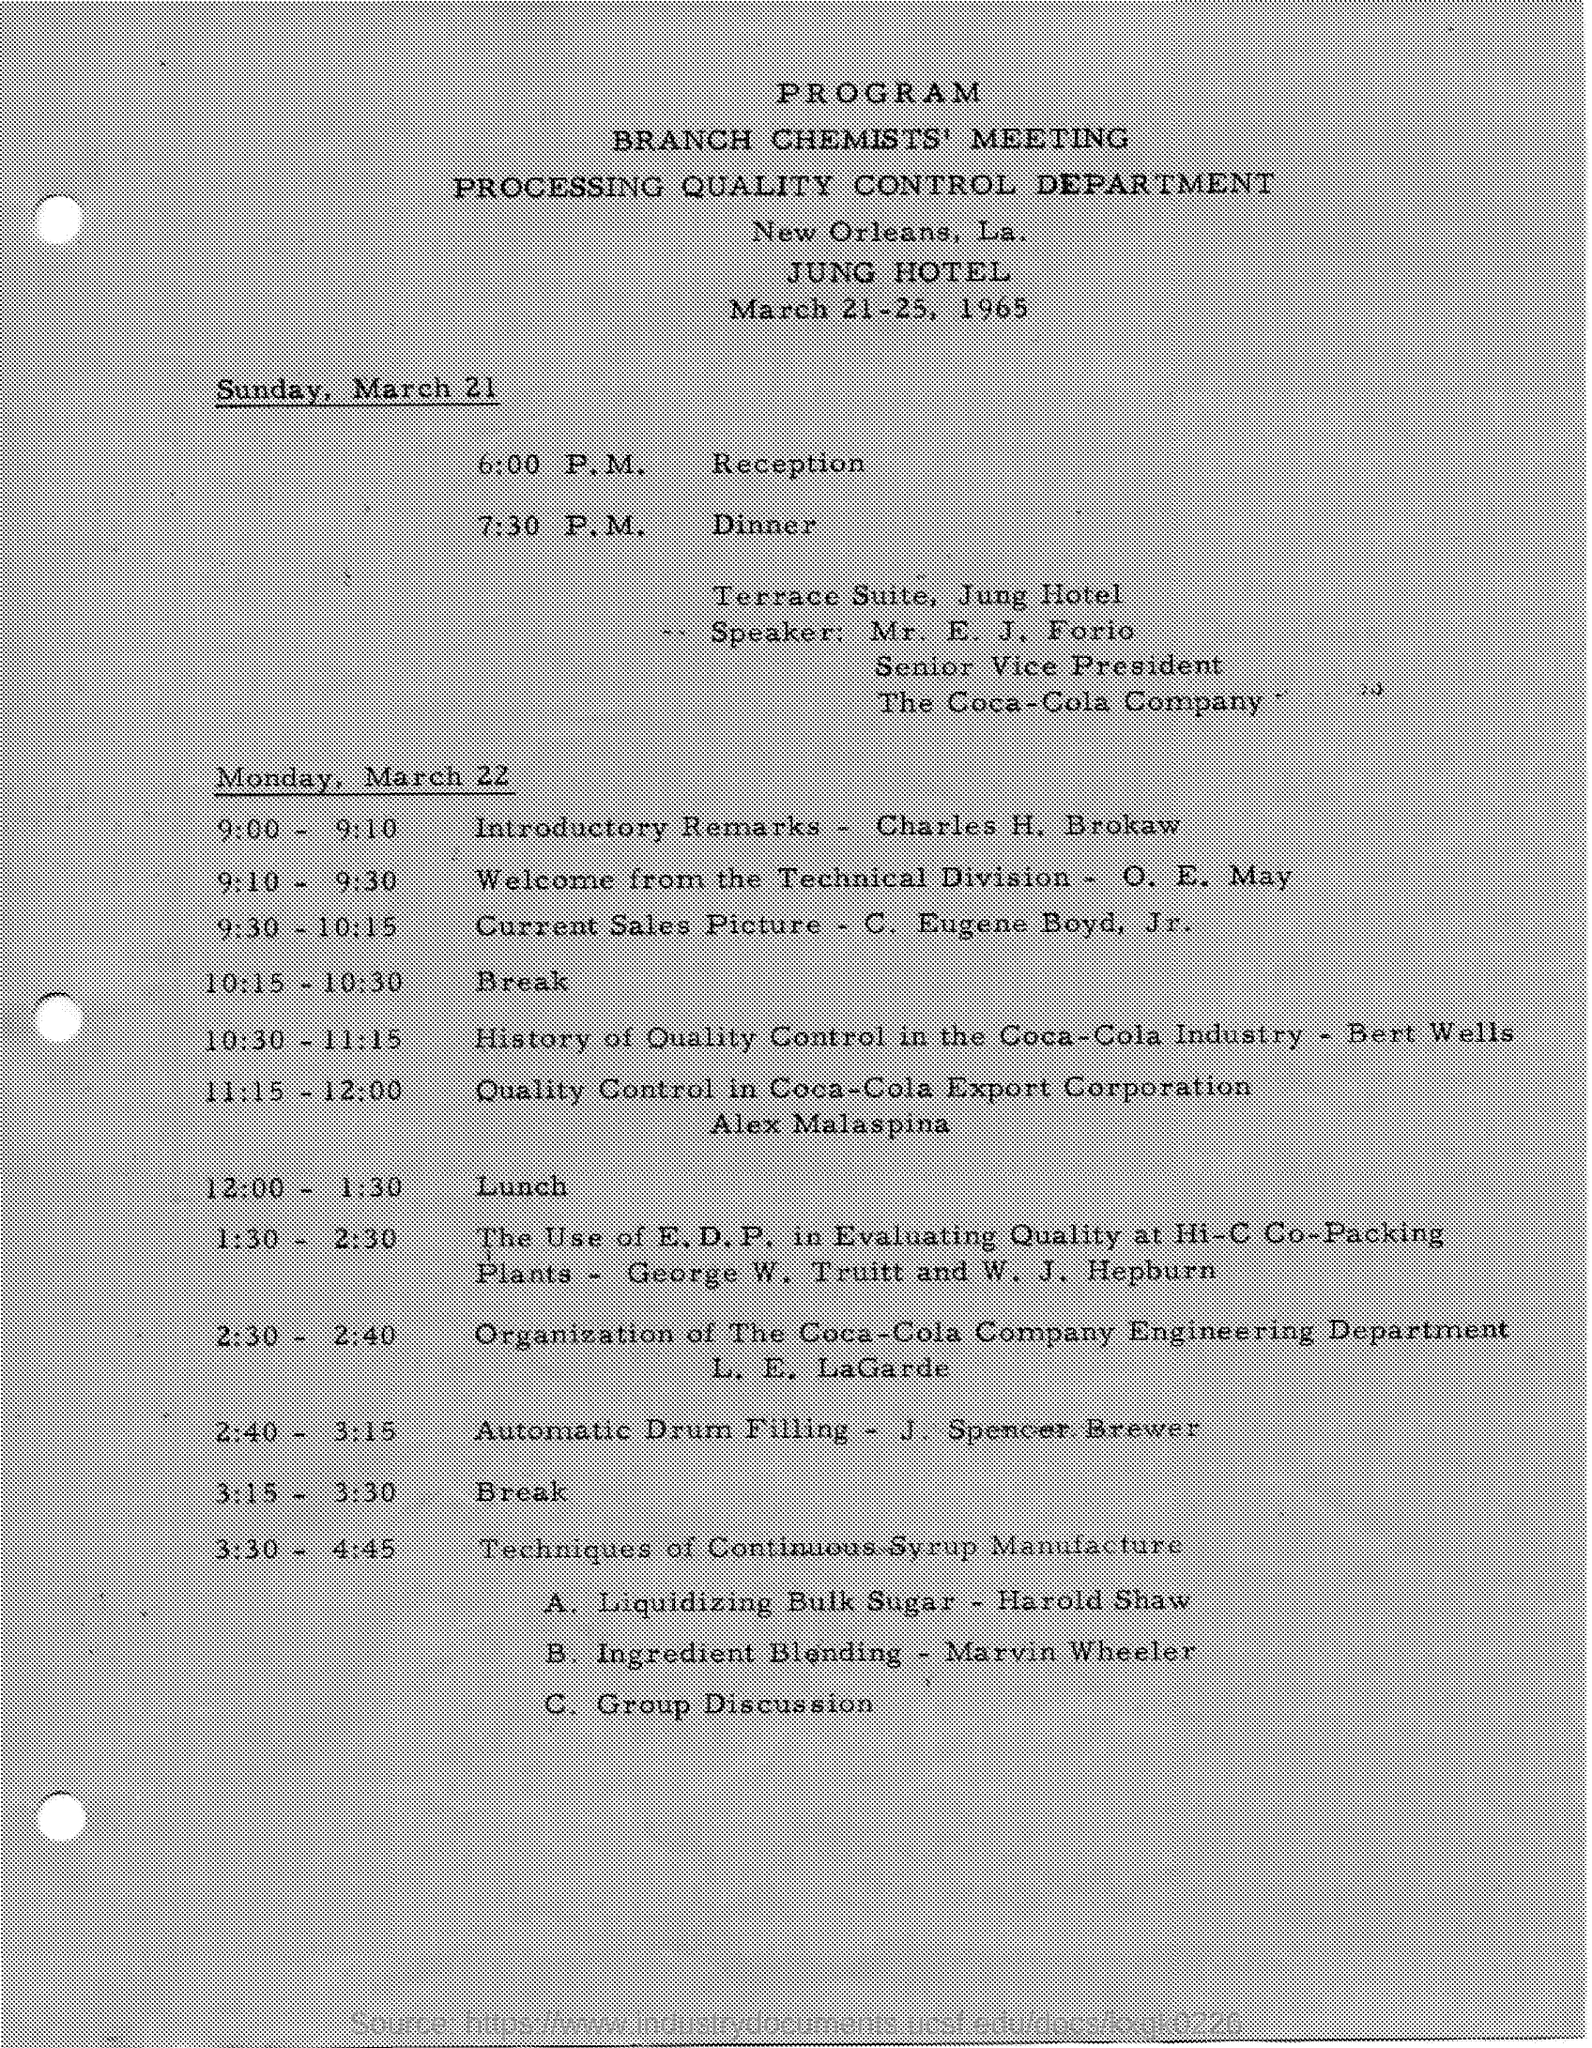In which hotel is the meeting going to be held?
Give a very brief answer. Jung hotel. Who is the speaker on March 21?
Your answer should be very brief. Mr. e. j. forio. What is E. J. Forio's designation?
Your answer should be very brief. Senior vice president. Which company is Forio the Senior Vice President of?
Give a very brief answer. The coca-cola company. Who will give the Introductory Remarks on March 22?
Give a very brief answer. Charles H. Brokaw. What is J. Spencer Brewer's topic from 2:40 - 3:15?
Your response must be concise. Automatic Drum Filling. 